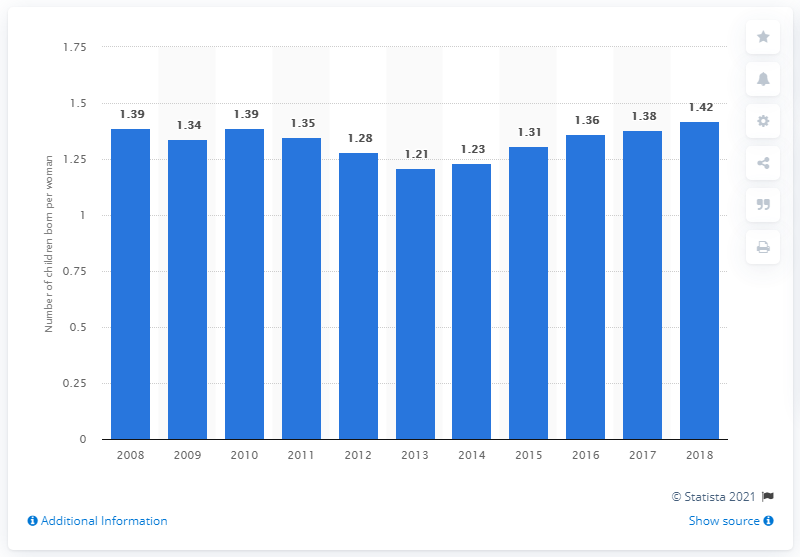How does Portugal's fertility rate in 2018 compare with earlier years? The fertility rate in Portugal in 2018 is slightly higher than in the preceding five years, an indication of a modest recovery from previous lows. It remains lower, however, than the rates observed in 2008 and 2010. What might be the significance of these fluctuations in fertility rate? Fertility rate fluctuations can impact demographic trends, economic planning, and social services. A lower fertility rate may point to an aging population, while a higher rate could lead to a younger, potentially larger workforce. These changes could require adjustments in areas such as education, healthcare, and employment. 